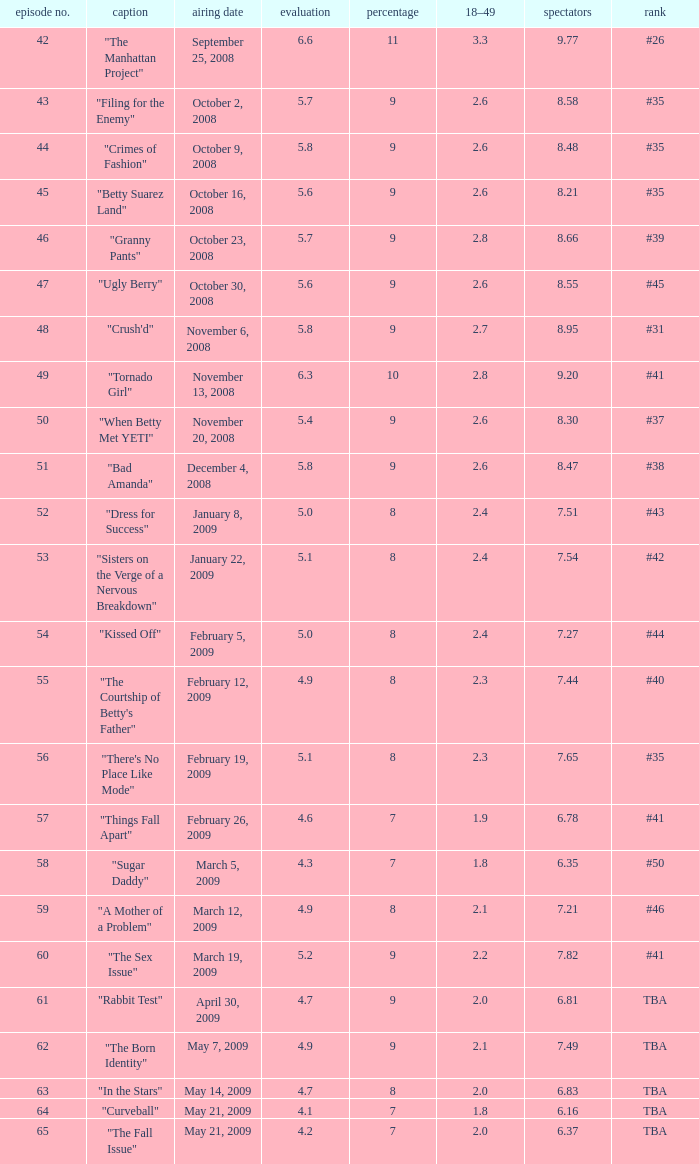What is the Air Date that has a 18–49 larger than 1.9, less than 7.54 viewers and a rating less than 4.9? April 30, 2009, May 14, 2009, May 21, 2009. 